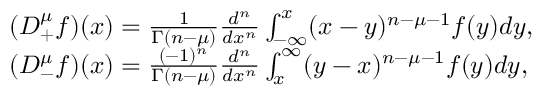Convert formula to latex. <formula><loc_0><loc_0><loc_500><loc_500>\begin{array} { r l } & { ( D _ { + } ^ { \mu } f ) ( x ) = \frac { 1 } { \Gamma ( n - \mu ) } \frac { d ^ { n } } { d x ^ { n } } \int _ { - \infty } ^ { x } ( x - y ) ^ { n - \mu - 1 } f ( y ) d y , } \\ & { ( D _ { - } ^ { \mu } f ) ( x ) = \frac { ( - 1 ) ^ { n } } { \Gamma ( n - \mu ) } \frac { d ^ { n } } { d x ^ { n } } \int _ { x } ^ { \infty } ( y - x ) ^ { n - \mu - 1 } f ( y ) d y , } \end{array}</formula> 